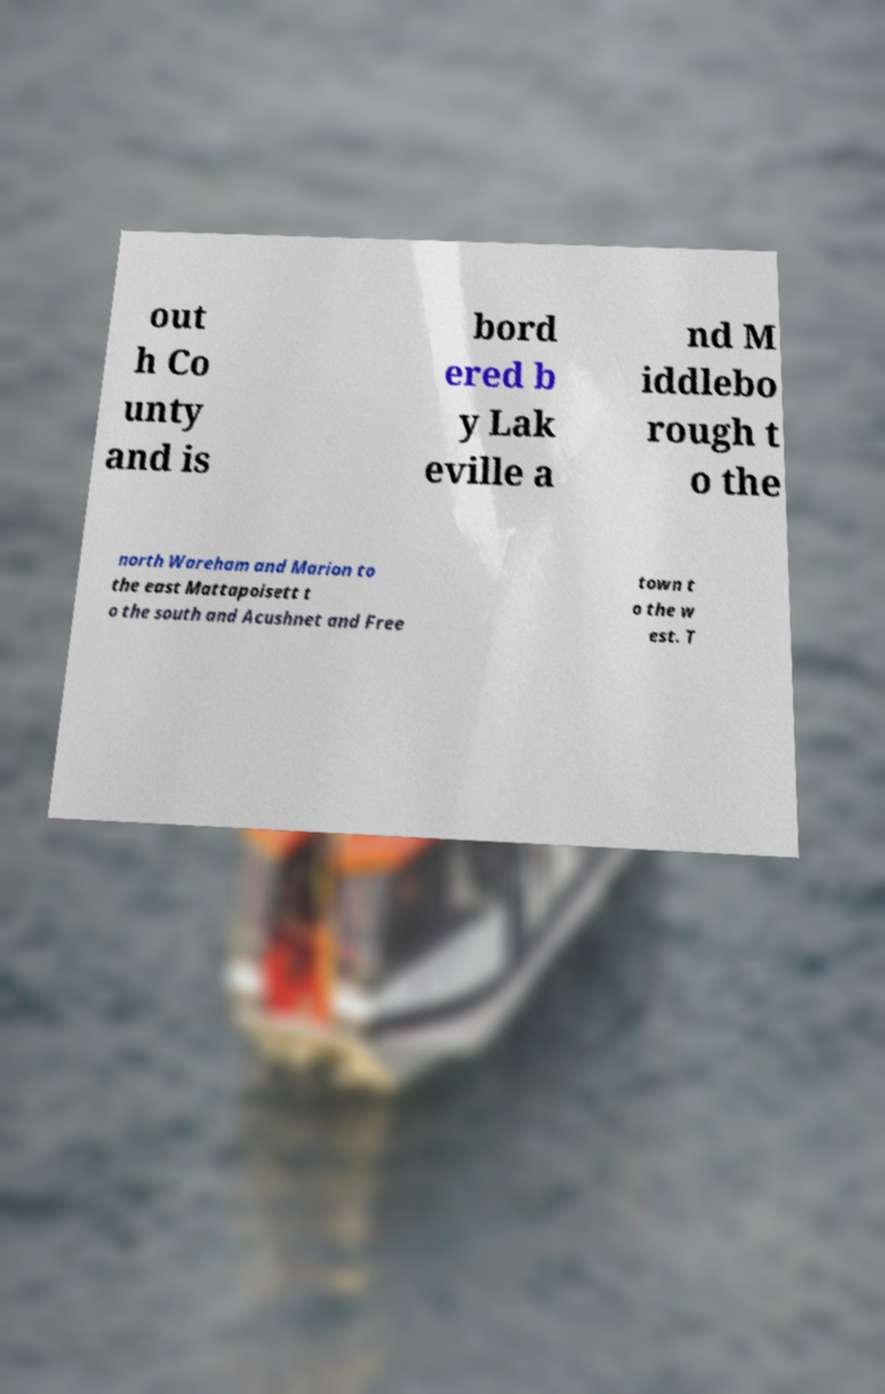Please read and relay the text visible in this image. What does it say? out h Co unty and is bord ered b y Lak eville a nd M iddlebo rough t o the north Wareham and Marion to the east Mattapoisett t o the south and Acushnet and Free town t o the w est. T 